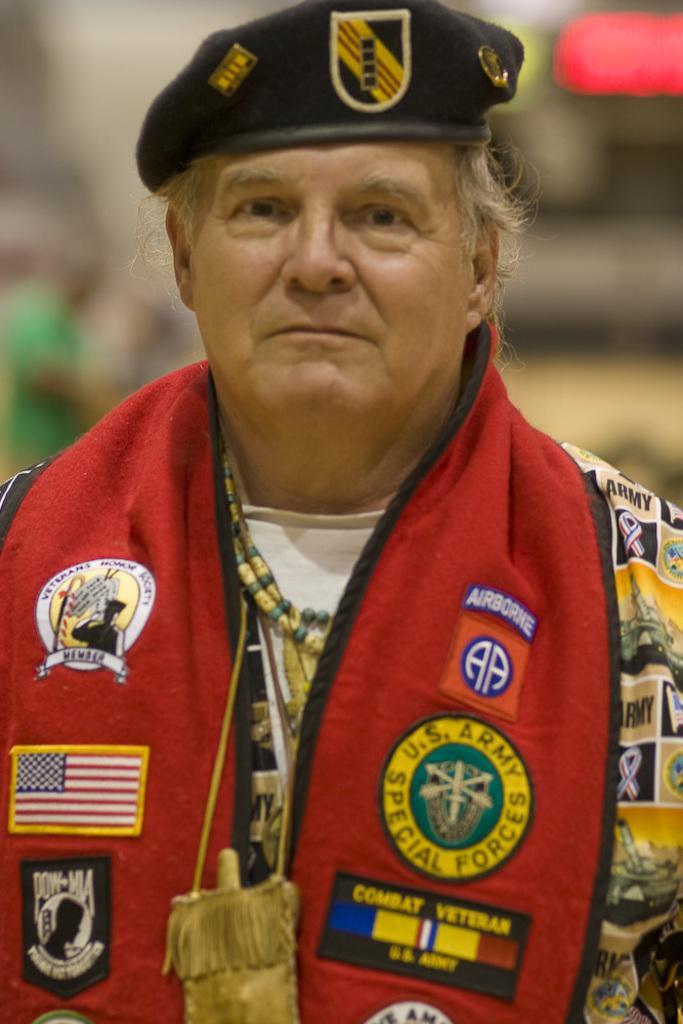Could you give a brief overview of what you see in this image? In the image a person is standing and smiling. Background of the image is blur. 